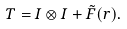Convert formula to latex. <formula><loc_0><loc_0><loc_500><loc_500>T = I \otimes I + \tilde { F } ( r ) .</formula> 